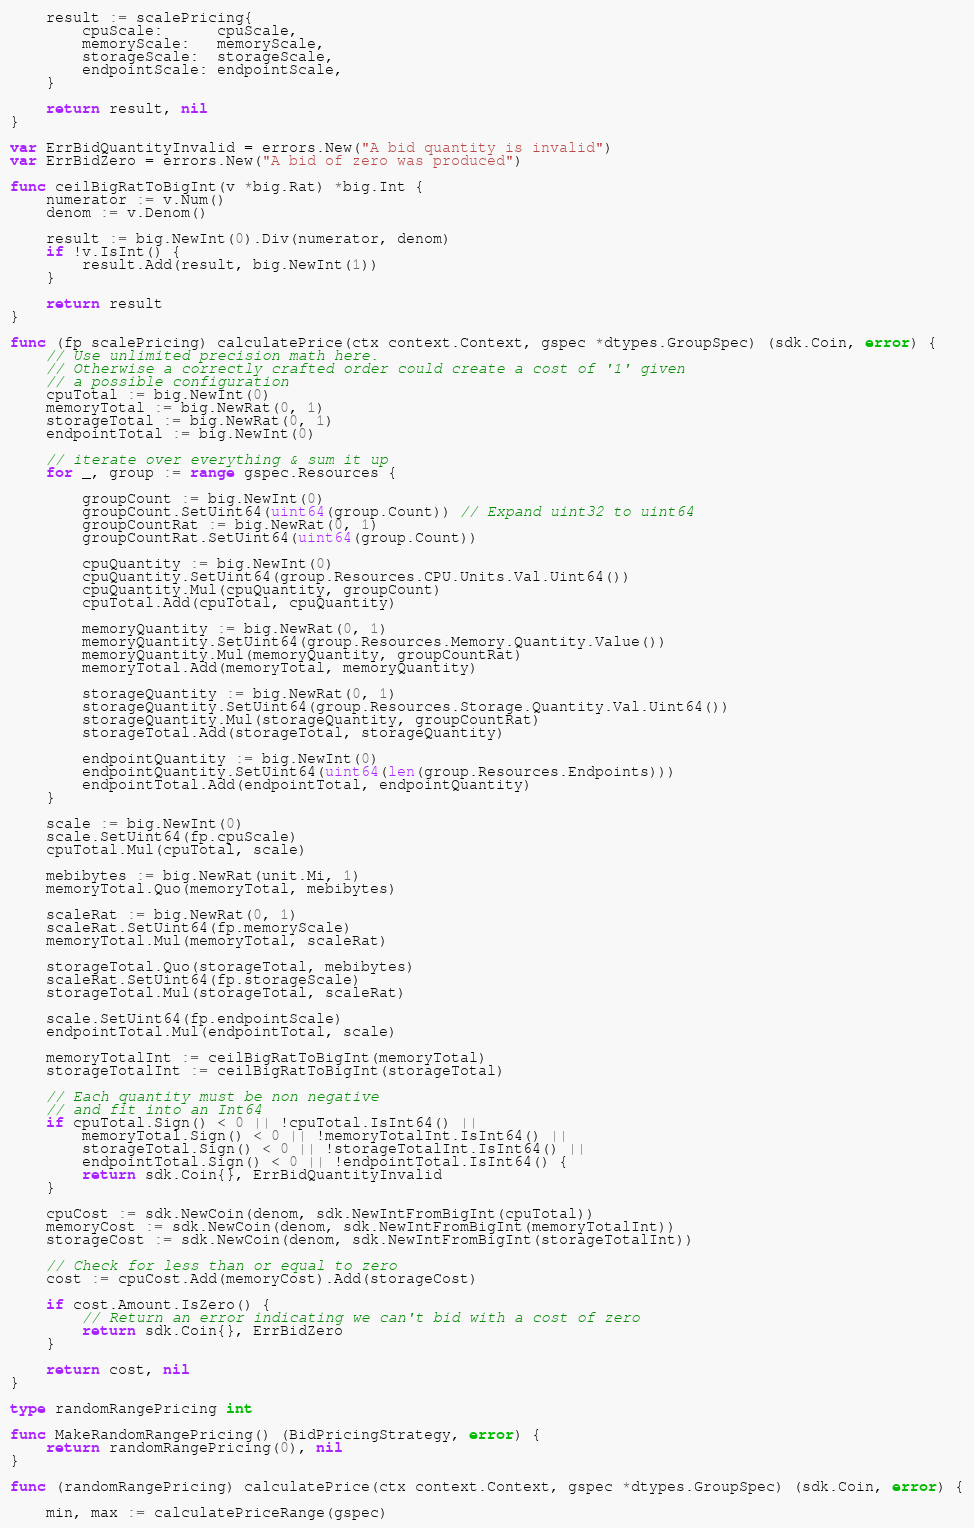Convert code to text. <code><loc_0><loc_0><loc_500><loc_500><_Go_>
	result := scalePricing{
		cpuScale:      cpuScale,
		memoryScale:   memoryScale,
		storageScale:  storageScale,
		endpointScale: endpointScale,
	}

	return result, nil
}

var ErrBidQuantityInvalid = errors.New("A bid quantity is invalid")
var ErrBidZero = errors.New("A bid of zero was produced")

func ceilBigRatToBigInt(v *big.Rat) *big.Int {
	numerator := v.Num()
	denom := v.Denom()

	result := big.NewInt(0).Div(numerator, denom)
	if !v.IsInt() {
		result.Add(result, big.NewInt(1))
	}

	return result
}

func (fp scalePricing) calculatePrice(ctx context.Context, gspec *dtypes.GroupSpec) (sdk.Coin, error) {
	// Use unlimited precision math here.
	// Otherwise a correctly crafted order could create a cost of '1' given
	// a possible configuration
	cpuTotal := big.NewInt(0)
	memoryTotal := big.NewRat(0, 1)
	storageTotal := big.NewRat(0, 1)
	endpointTotal := big.NewInt(0)

	// iterate over everything & sum it up
	for _, group := range gspec.Resources {

		groupCount := big.NewInt(0)
		groupCount.SetUint64(uint64(group.Count)) // Expand uint32 to uint64
		groupCountRat := big.NewRat(0, 1)
		groupCountRat.SetUint64(uint64(group.Count))

		cpuQuantity := big.NewInt(0)
		cpuQuantity.SetUint64(group.Resources.CPU.Units.Val.Uint64())
		cpuQuantity.Mul(cpuQuantity, groupCount)
		cpuTotal.Add(cpuTotal, cpuQuantity)

		memoryQuantity := big.NewRat(0, 1)
		memoryQuantity.SetUint64(group.Resources.Memory.Quantity.Value())
		memoryQuantity.Mul(memoryQuantity, groupCountRat)
		memoryTotal.Add(memoryTotal, memoryQuantity)

		storageQuantity := big.NewRat(0, 1)
		storageQuantity.SetUint64(group.Resources.Storage.Quantity.Val.Uint64())
		storageQuantity.Mul(storageQuantity, groupCountRat)
		storageTotal.Add(storageTotal, storageQuantity)

		endpointQuantity := big.NewInt(0)
		endpointQuantity.SetUint64(uint64(len(group.Resources.Endpoints)))
		endpointTotal.Add(endpointTotal, endpointQuantity)
	}

	scale := big.NewInt(0)
	scale.SetUint64(fp.cpuScale)
	cpuTotal.Mul(cpuTotal, scale)

	mebibytes := big.NewRat(unit.Mi, 1)
	memoryTotal.Quo(memoryTotal, mebibytes)

	scaleRat := big.NewRat(0, 1)
	scaleRat.SetUint64(fp.memoryScale)
	memoryTotal.Mul(memoryTotal, scaleRat)

	storageTotal.Quo(storageTotal, mebibytes)
	scaleRat.SetUint64(fp.storageScale)
	storageTotal.Mul(storageTotal, scaleRat)

	scale.SetUint64(fp.endpointScale)
	endpointTotal.Mul(endpointTotal, scale)

	memoryTotalInt := ceilBigRatToBigInt(memoryTotal)
	storageTotalInt := ceilBigRatToBigInt(storageTotal)

	// Each quantity must be non negative
	// and fit into an Int64
	if cpuTotal.Sign() < 0 || !cpuTotal.IsInt64() ||
		memoryTotal.Sign() < 0 || !memoryTotalInt.IsInt64() ||
		storageTotal.Sign() < 0 || !storageTotalInt.IsInt64() ||
		endpointTotal.Sign() < 0 || !endpointTotal.IsInt64() {
		return sdk.Coin{}, ErrBidQuantityInvalid
	}

	cpuCost := sdk.NewCoin(denom, sdk.NewIntFromBigInt(cpuTotal))
	memoryCost := sdk.NewCoin(denom, sdk.NewIntFromBigInt(memoryTotalInt))
	storageCost := sdk.NewCoin(denom, sdk.NewIntFromBigInt(storageTotalInt))

	// Check for less than or equal to zero
	cost := cpuCost.Add(memoryCost).Add(storageCost)

	if cost.Amount.IsZero() {
		// Return an error indicating we can't bid with a cost of zero
		return sdk.Coin{}, ErrBidZero
	}

	return cost, nil
}

type randomRangePricing int

func MakeRandomRangePricing() (BidPricingStrategy, error) {
	return randomRangePricing(0), nil
}

func (randomRangePricing) calculatePrice(ctx context.Context, gspec *dtypes.GroupSpec) (sdk.Coin, error) {

	min, max := calculatePriceRange(gspec)
</code> 